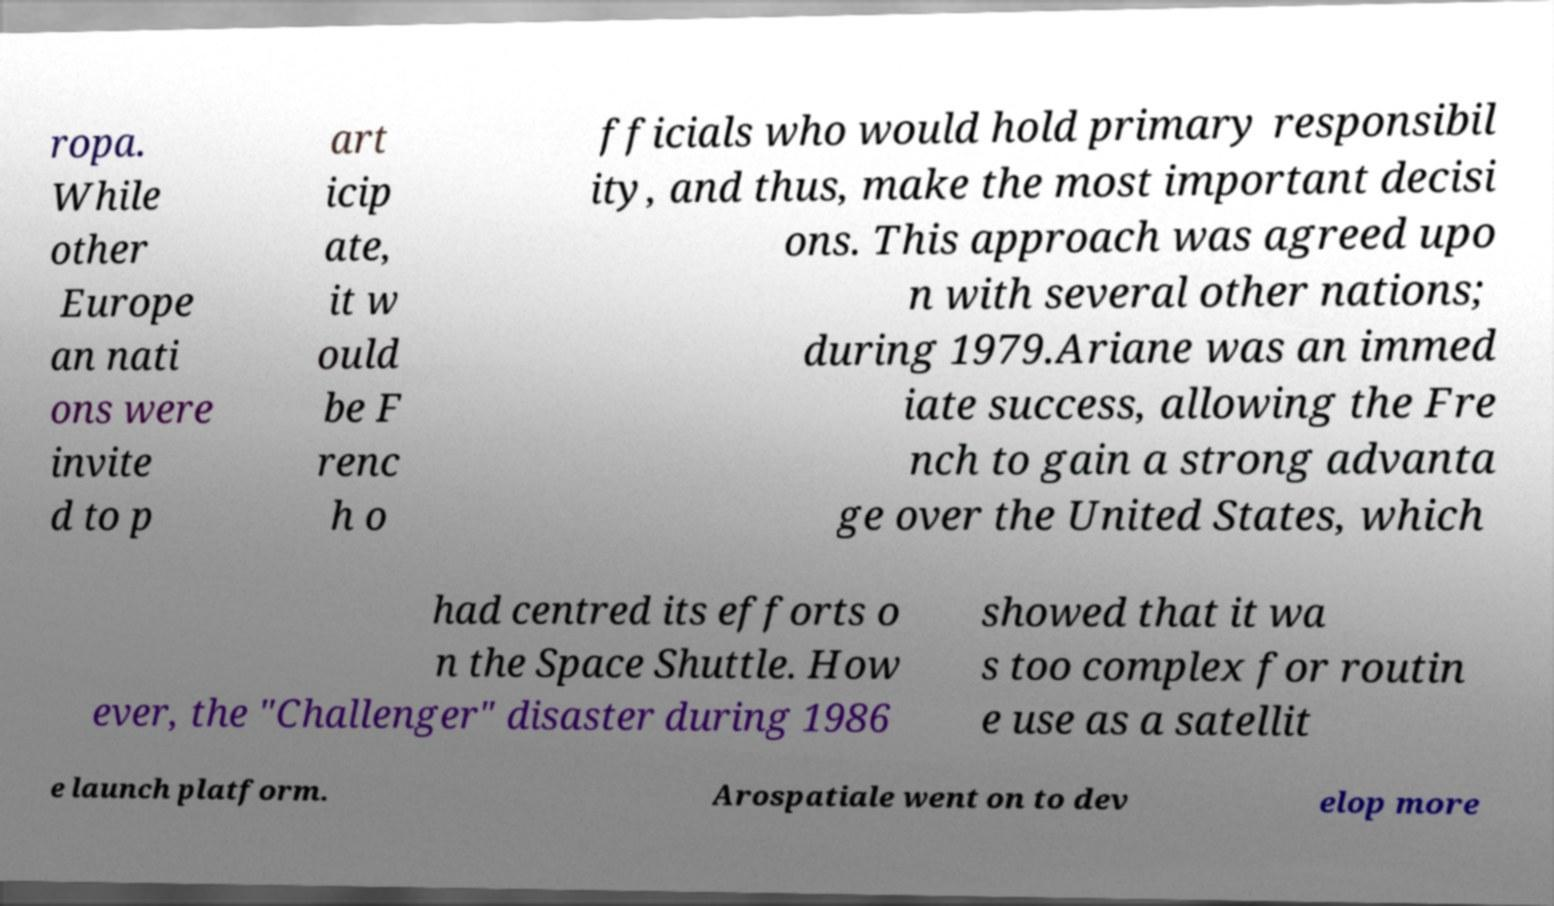For documentation purposes, I need the text within this image transcribed. Could you provide that? ropa. While other Europe an nati ons were invite d to p art icip ate, it w ould be F renc h o fficials who would hold primary responsibil ity, and thus, make the most important decisi ons. This approach was agreed upo n with several other nations; during 1979.Ariane was an immed iate success, allowing the Fre nch to gain a strong advanta ge over the United States, which had centred its efforts o n the Space Shuttle. How ever, the "Challenger" disaster during 1986 showed that it wa s too complex for routin e use as a satellit e launch platform. Arospatiale went on to dev elop more 